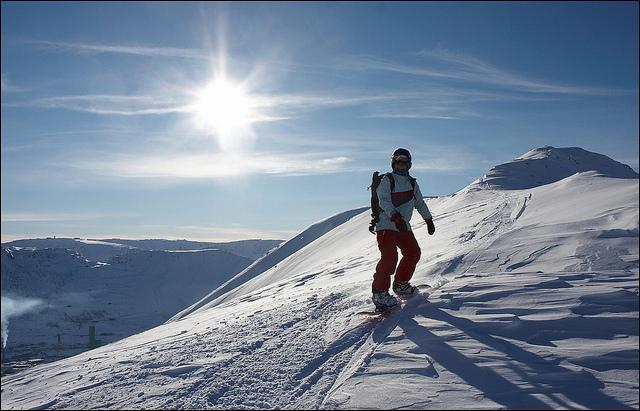Which direction will this person most likely go next? Please explain your reasoning. down slop. The direction is down. 